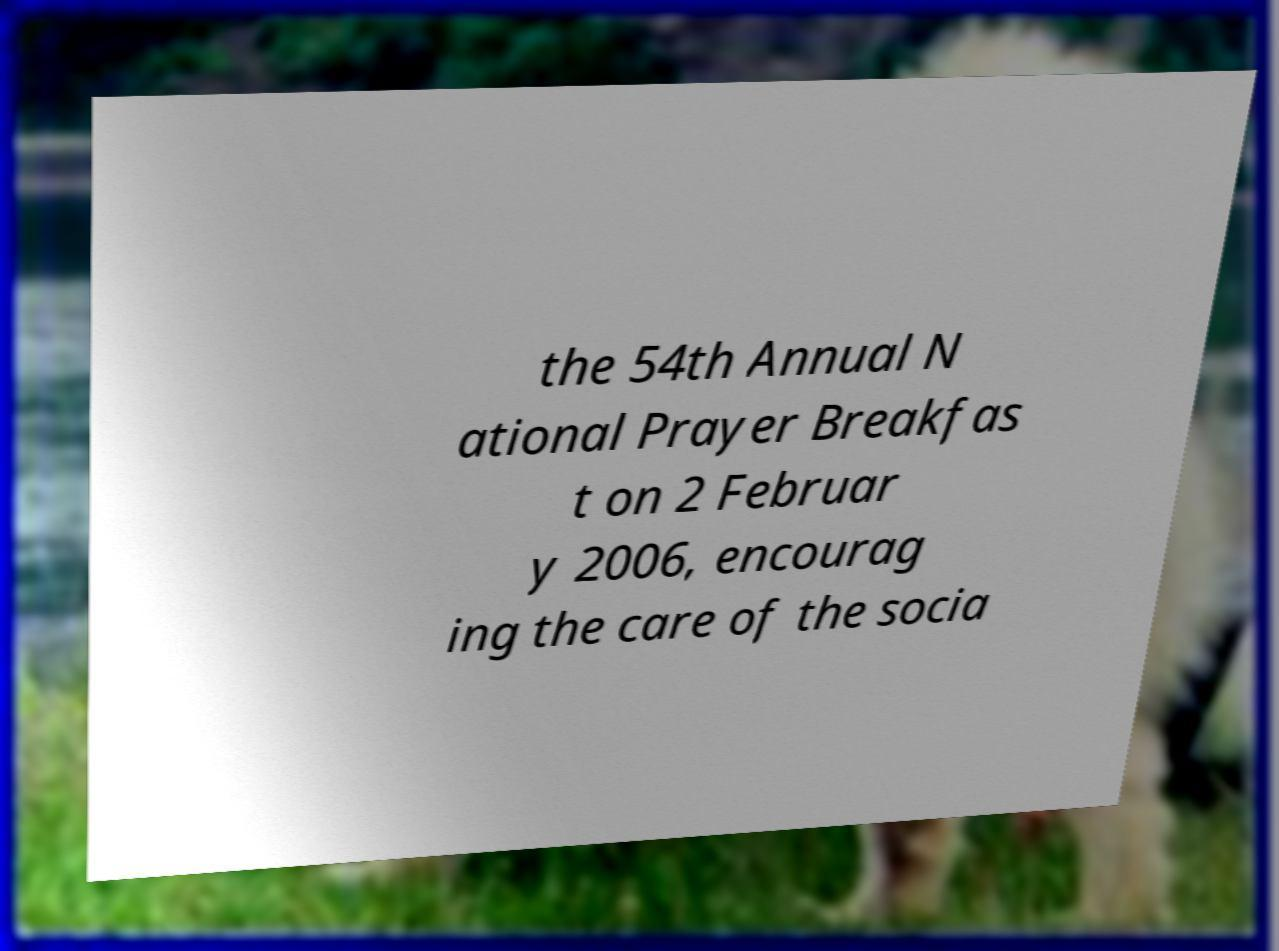What messages or text are displayed in this image? I need them in a readable, typed format. the 54th Annual N ational Prayer Breakfas t on 2 Februar y 2006, encourag ing the care of the socia 